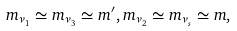Convert formula to latex. <formula><loc_0><loc_0><loc_500><loc_500>m _ { \nu _ { 1 } } \simeq m _ { \nu _ { 3 } } \simeq m ^ { \prime } , m _ { \nu _ { 2 } } \simeq m _ { \nu _ { s } } \simeq m ,</formula> 